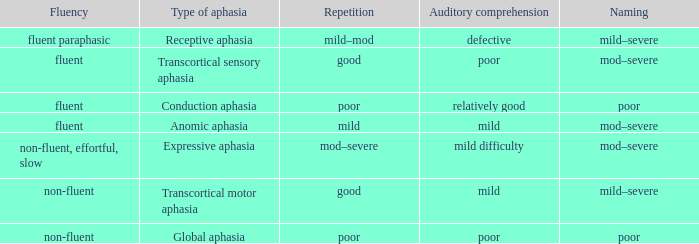Name the comprehension for non-fluent, effortful, slow Mild difficulty. 